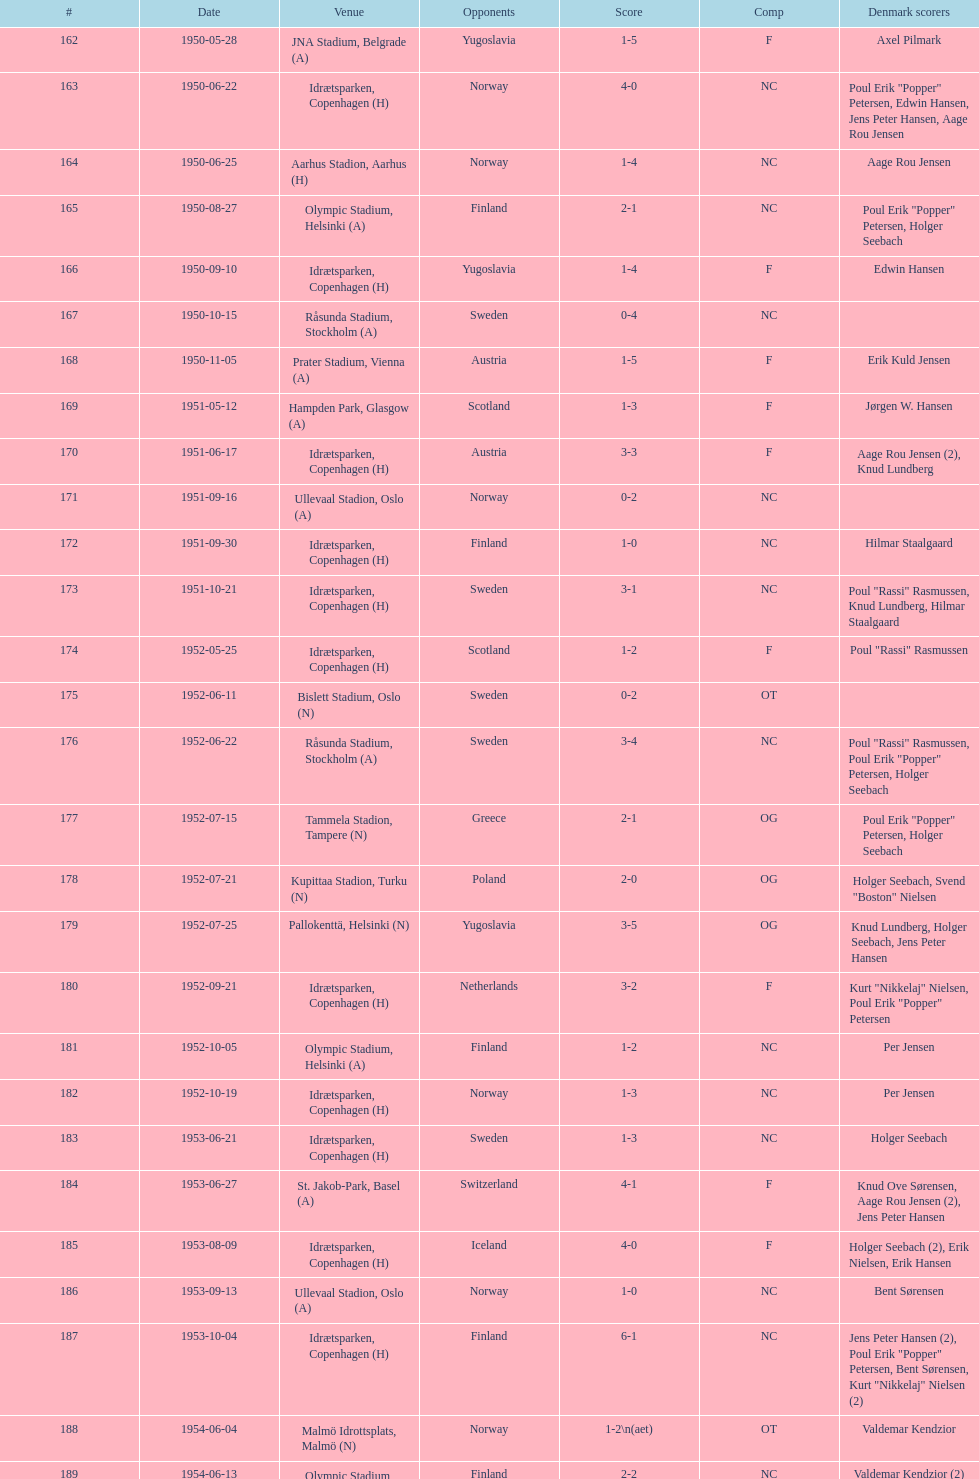What is the appellation of the site noted preceding olympic stadium on 1950-08-27? Aarhus Stadion, Aarhus. 